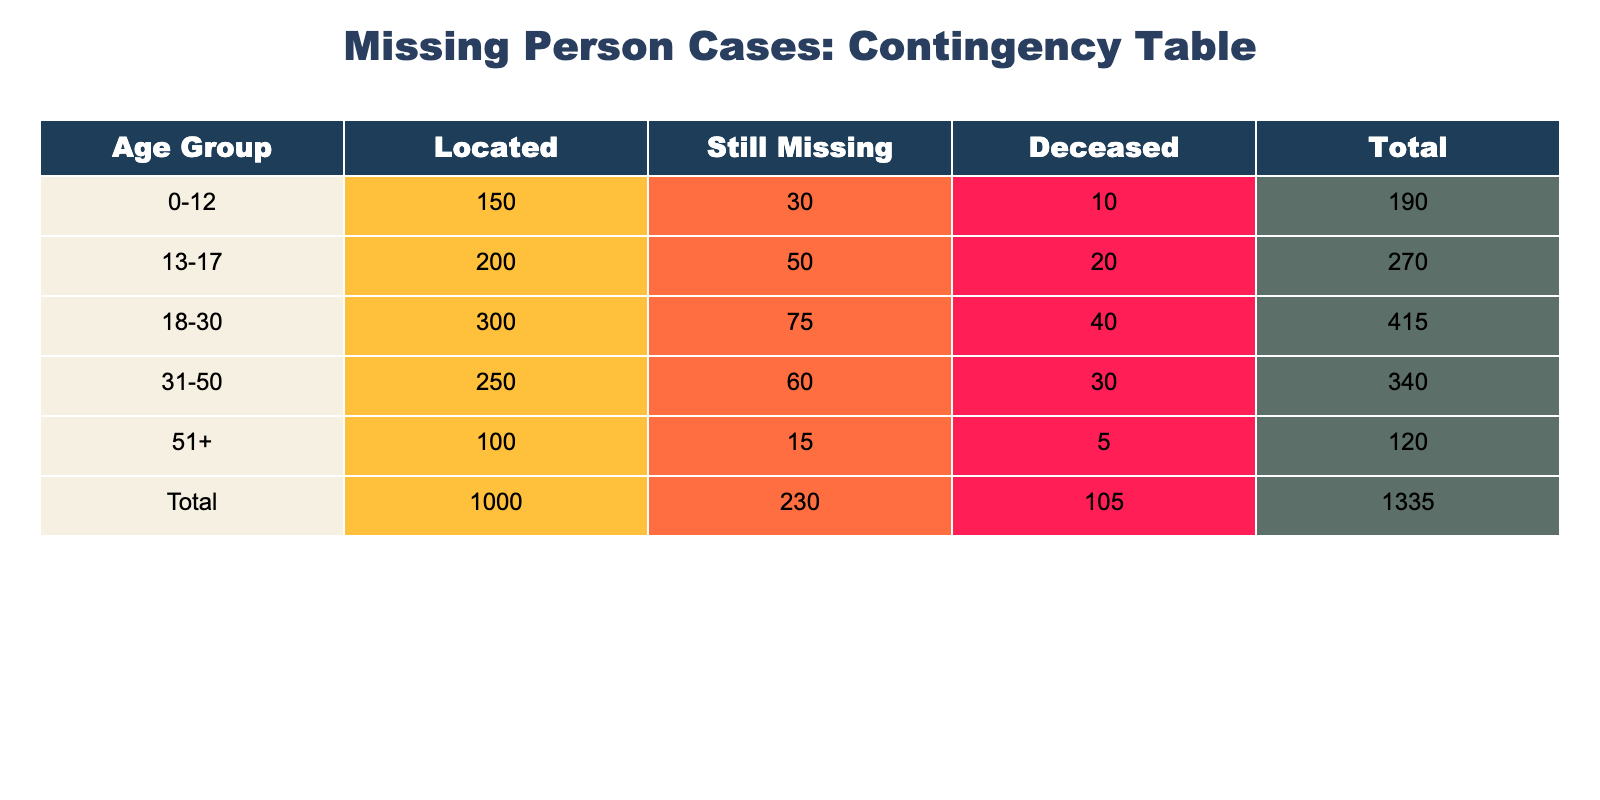What is the total number of missing persons located in the 18-30 age group? In the table, under the '18-30' age group, the 'Located' status shows a frequency of 300. Therefore, the total number of missing persons located in this group is 300.
Answer: 300 How many individuals aged 51 and older are still missing? For the age group '51+', the 'Still Missing' status has a frequency of 15. Therefore, 15 individuals aged 51 and older are still missing.
Answer: 15 Which age group has the highest number of deceased cases? By reviewing the 'Deceased' status across all age groups, '18-30' has 40, '31-50' has 30, '13-17' has 20, and '0-12' has 10. The '18-30' age group shows the highest frequency of 40 deceased cases.
Answer: 18-30 What is the total number of individuals still missing across all age groups? To find the total number of individuals still missing, I sum the frequencies of the 'Still Missing' status across all age groups: 30 (0-12) + 50 (13-17) + 75 (18-30) + 60 (31-50) + 15 (51+) = 230.
Answer: 230 Is the number of located individuals greater than the number of deceased individuals in the 0-12 age group? In the '0-12' age group, the number of located individuals is 150 and the number of deceased individuals is 10. Since 150 is greater than 10, the statement is true.
Answer: Yes What is the average number of individuals located across all age groups? To calculate the average, I first sum the numbers of located individuals: 150 (0-12) + 200 (13-17) + 300 (18-30) + 250 (31-50) + 100 (51+) = 1000. There are 5 age groups, so the average is 1000/5 = 200.
Answer: 200 How many total cases were there in the 31-50 age group? In the '31-50' age group, the frequencies are: Located: 250, Still Missing: 60, Deceased: 30. Adding these gives 250 + 60 + 30 = 340. Thus, the total cases are 340.
Answer: 340 What is the difference between the number of located individuals in the age group 18-30 and those still missing in the same age group? In the age group '18-30', the number of located individuals is 300 and the number still missing is 75. The difference is calculated as 300 - 75 = 225.
Answer: 225 Which missing status has the least frequency among individuals aged 0-12? For the age group '0-12', the frequencies are: Located: 150, Still Missing: 30, Deceased: 10. The status with the least frequency is 'Deceased' with a frequency of 10.
Answer: Deceased 